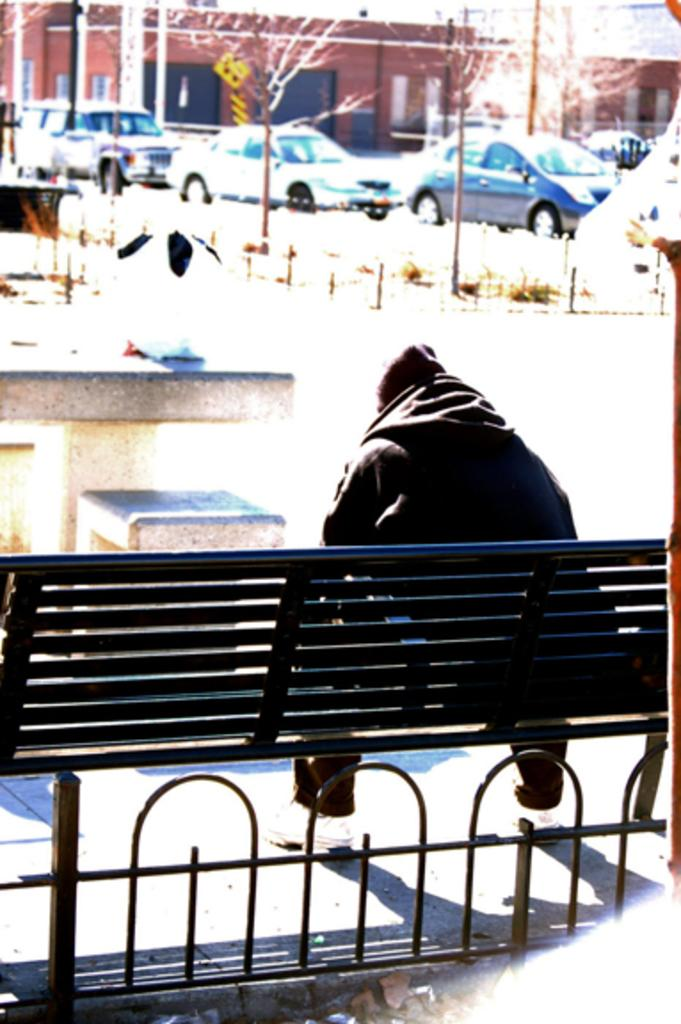What is the person in the image doing? There is a person sitting on a bench in the image. What is in front of the person? There is a fencing in front of the person. What can be seen behind the fencing? Cars, trees, and a building are visible behind the fencing. What type of jellyfish can be seen swimming near the person in the image? There is no jellyfish present in the image; it takes place in a setting with a bench, fencing, and a background of cars, trees, and a building. 